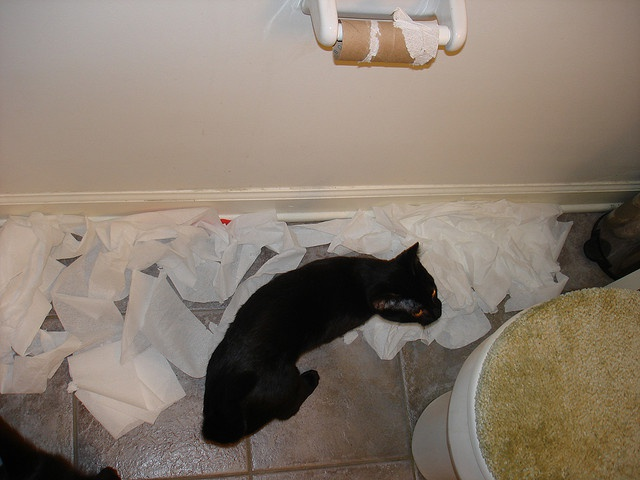Describe the objects in this image and their specific colors. I can see toilet in gray and olive tones and cat in gray, black, and maroon tones in this image. 